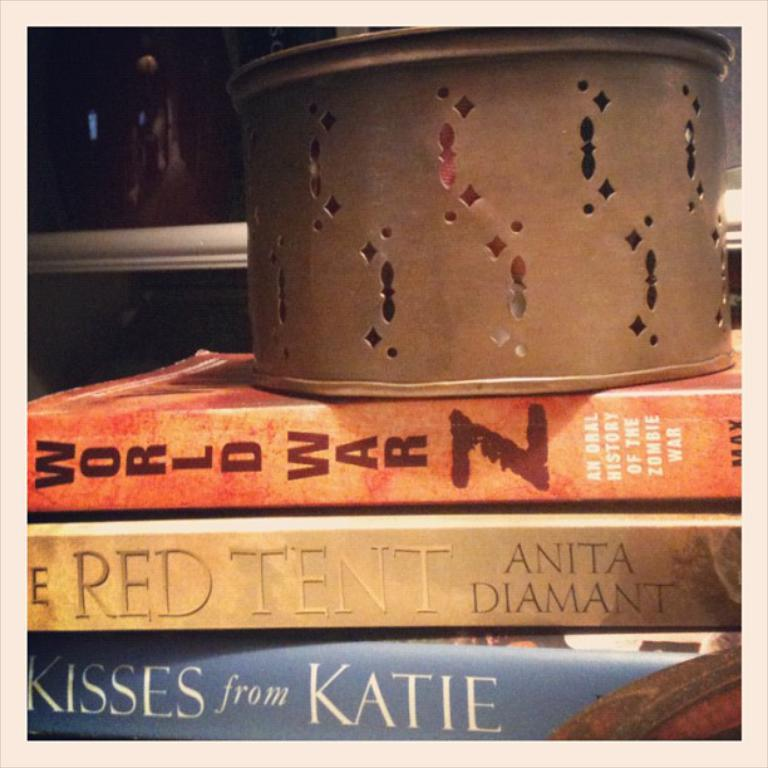<image>
Relay a brief, clear account of the picture shown. Several books and one that says Kisses from katie 